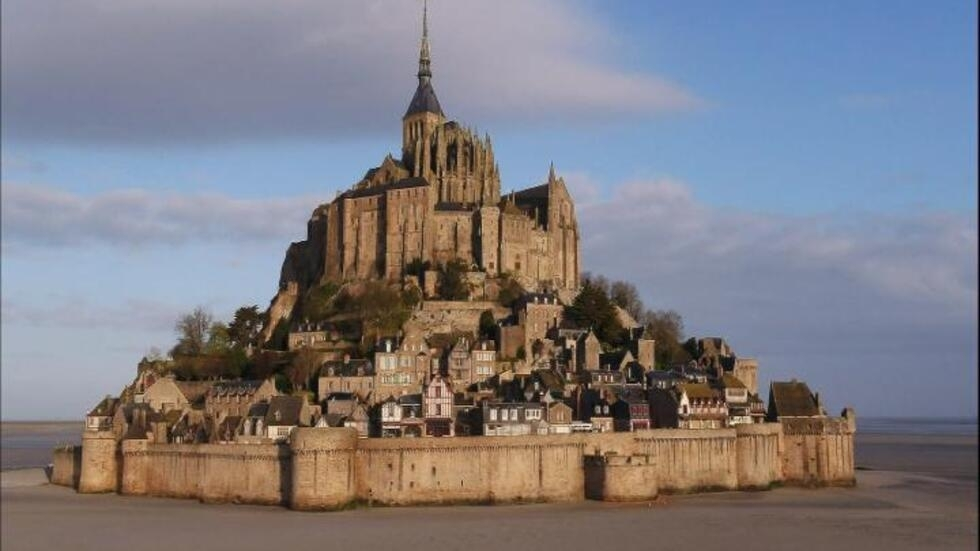If Mont Saint Michel could speak, what stories would it share? Mont Saint Michel would tell tales of ancient pilgrims who braved perilous journeys to seek solace and blessings within its walls. It would recount the tales of fierce battles and sieges, where its fortified walls stood steadfast against invaders. The abbey would share stories of monks dedicated to a life of prayer and scholarship, meticulously preserving knowledge through centuries. It might whisper about the countless visitors who have marveled at its grandeur while contributing to its ongoing legacy. And finally, it would talk about the timeless dance of the tides, shaping the island's existence and adding a magical rhythm to its daily life. 